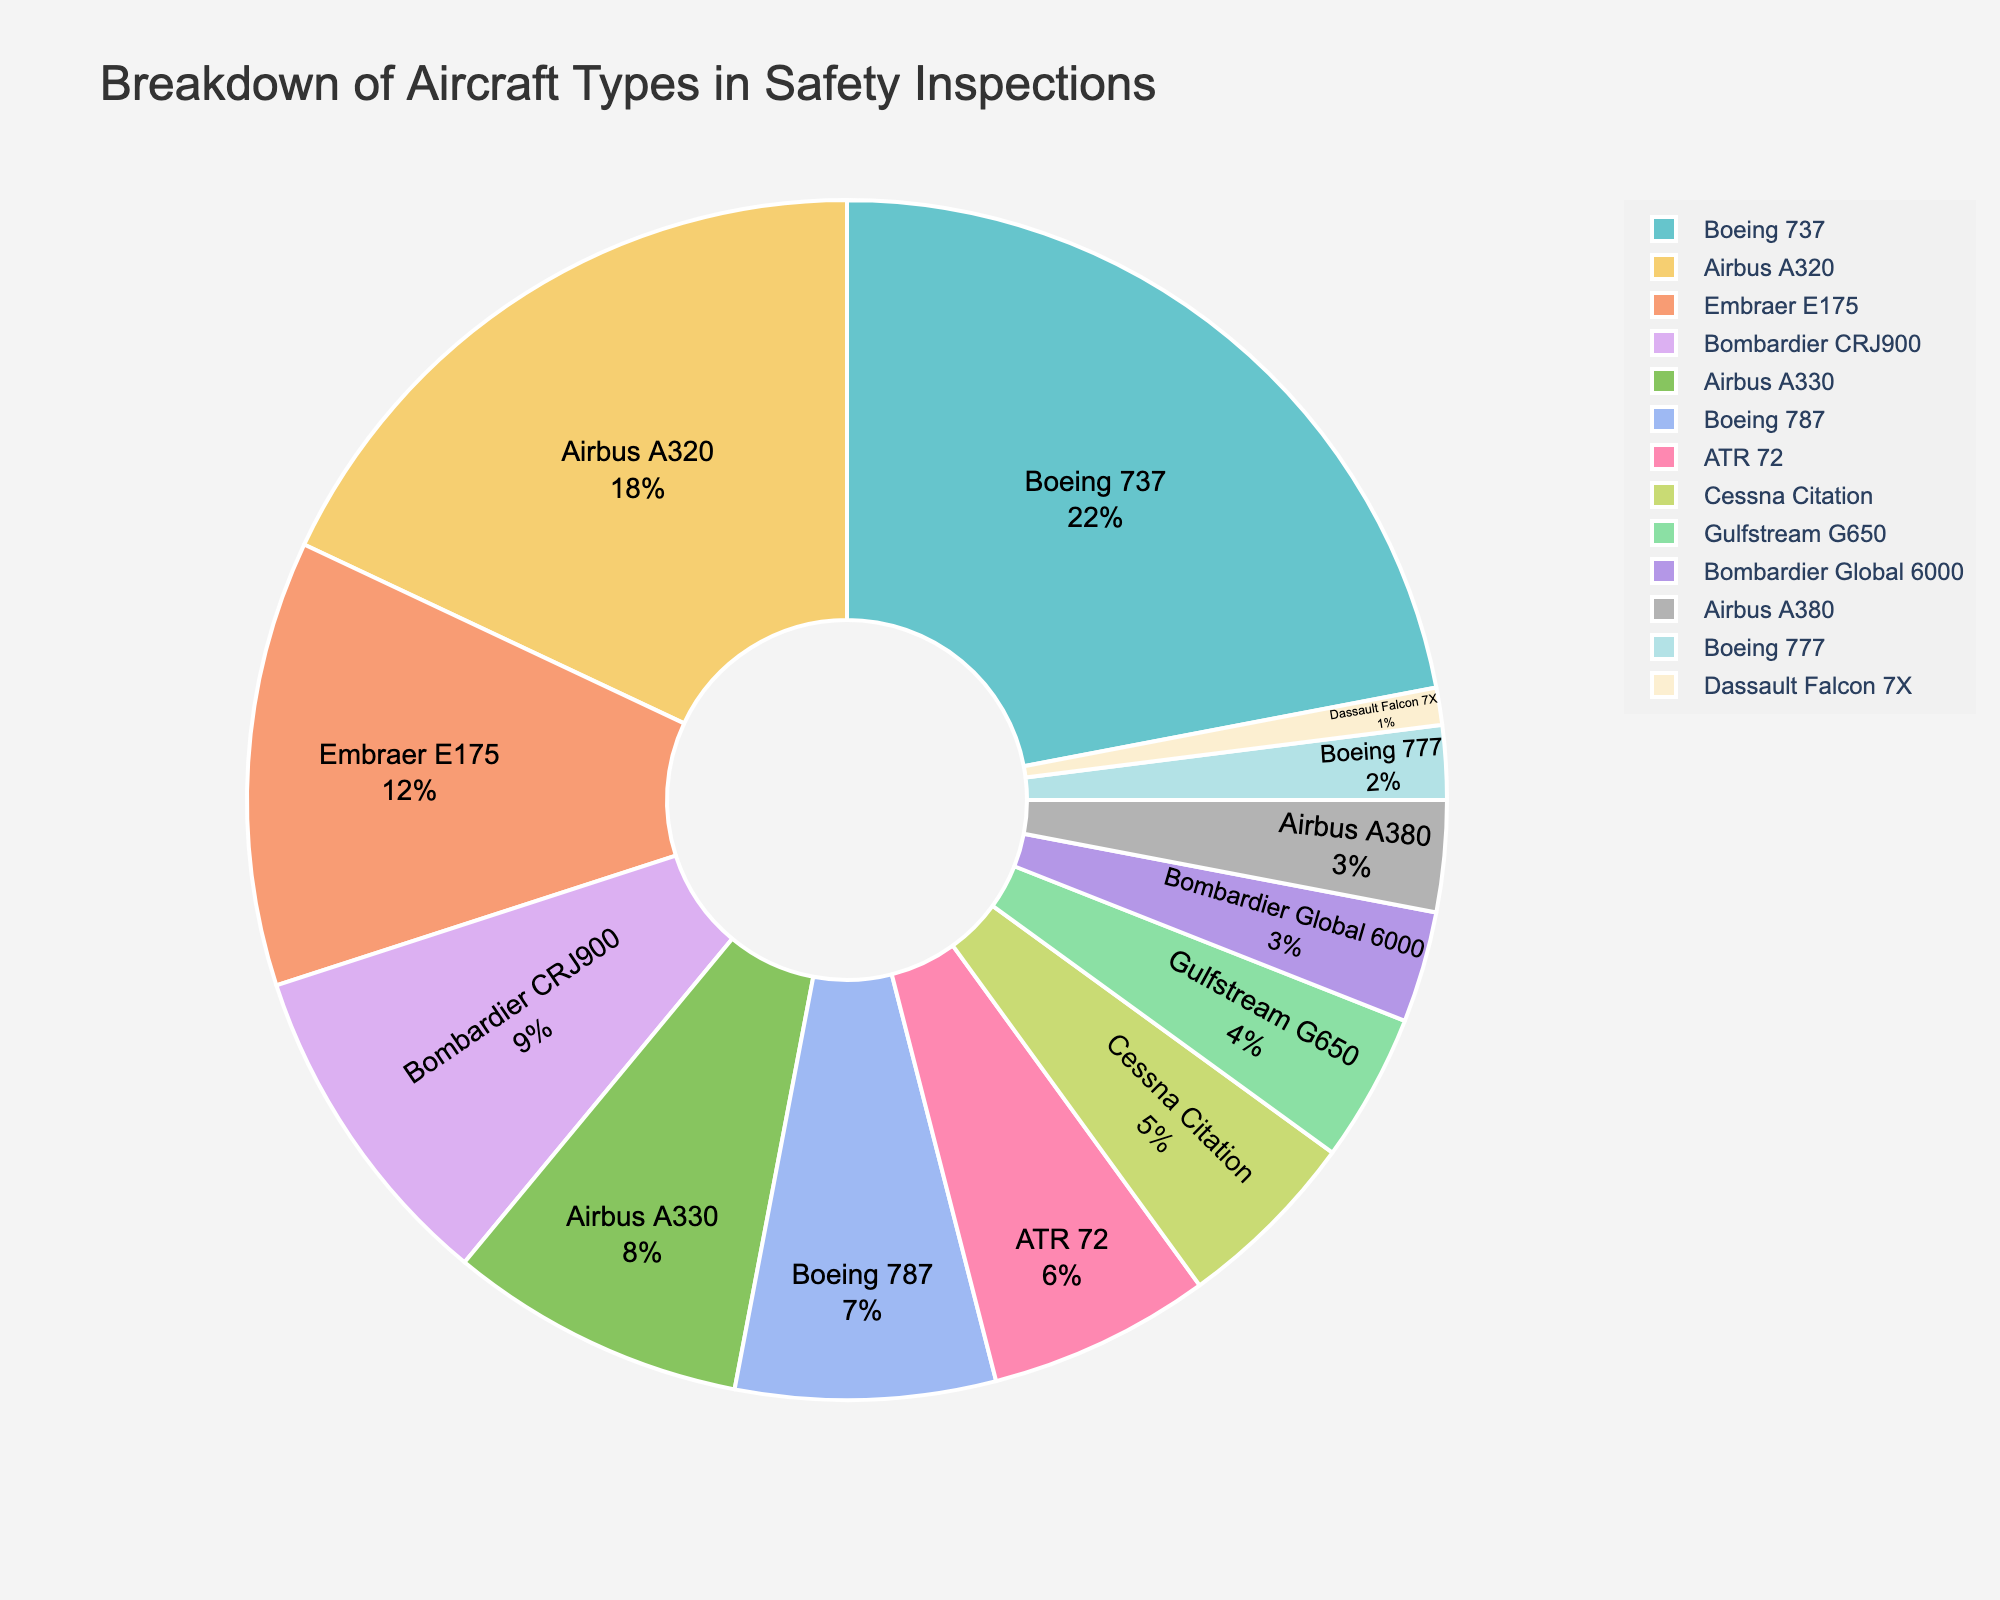Which aircraft type has the highest percentage in safety inspections? The Boeing 737 has the largest portion in the pie chart.
Answer: Boeing 737 What is the combined percentage of Boeing aircraft in safety inspections? Adding the percentages of Boeing 737 (22%), Boeing 787 (7%), and Boeing 777 (2%) gives 22 + 7 + 2 = 31%.
Answer: 31% How does the percentage of the ATR 72 compare to the Bombardier CRJ900? The ATR 72 has a percentage of 6%, while the Bombardier CRJ900 has 9%, meaning the Bombardier CRJ900 is higher.
Answer: Bombardier CRJ900 Which aircraft type has the smallest percentage in safety inspections? The Dassault Falcon 7X has the smallest portion in the pie chart with 1%.
Answer: Dassault Falcon 7X What is the total percentage of inspections involving Airbus aircraft? Summing the percentages of Airbus A320 (18%), Airbus A330 (8%), and Airbus A380 (3%) gives 18 + 8 + 3 = 29%.
Answer: 29% Is the percentage of the Embraer E175 more than twice that of the Gulfstream G650? The Embraer E175 has 12% and the Gulfstream G650 has 4%. Since 12% is exactly three times 4%, the percentage of the Embraer E175 is more than twice that of the Gulfstream G650.
Answer: Yes How does the percentage of the Airbus A320 compare to the sum of the Bombardier Global 6000 and Cessna Citation? The Airbus A320 has 18%, while the Bombardier Global 6000 (3%) and Cessna Citation (5%) together sum up to 3 + 5 = 8%. So, the Airbus A320 is higher.
Answer: Airbus A320 What is the difference in percentage points between the Bombardier CRJ900 and the Boeing 787? The Bombardier CRJ900 is at 9%, while the Boeing 787 is at 7%. The difference is 9 - 7 = 2%.
Answer: 2% What percentage of inspections involve either the ATR 72 or the Dassault Falcon 7X? The percentages for ATR 72 and Dassault Falcon 7X are 6% and 1%, respectively. Therefore, the combined percentage is 6 + 1 = 7%.
Answer: 7% What is the percentage difference between the most inspected Boeing aircraft and the most inspected Airbus aircraft? The Boeing 737 (most inspected Boeing aircraft) is 22% and the Airbus A320 (most inspected Airbus aircraft) is 18%. The difference is 22 - 18 = 4%.
Answer: 4% 